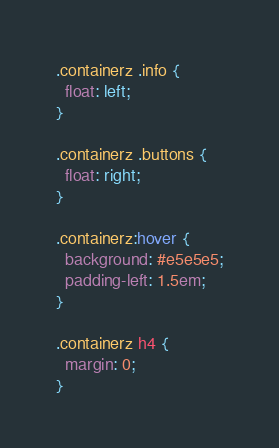<code> <loc_0><loc_0><loc_500><loc_500><_CSS_>
.containerz .info {
  float: left;
}

.containerz .buttons {
  float: right;
}

.containerz:hover {
  background: #e5e5e5;
  padding-left: 1.5em;
}

.containerz h4 {
  margin: 0;
}
</code> 